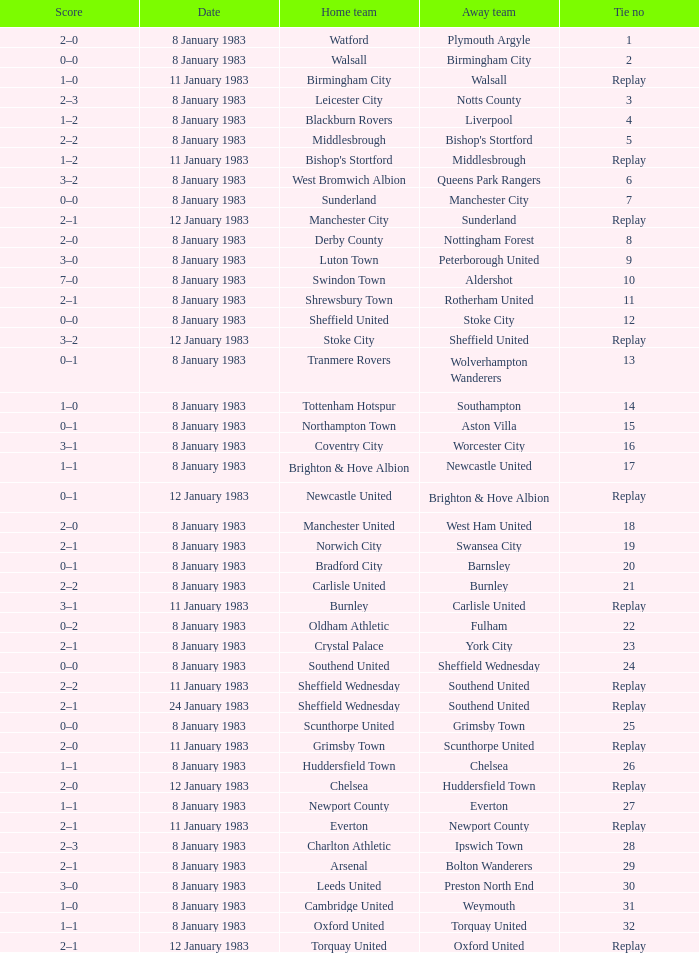In the tie where Southampton was the away team, who was the home team? Tottenham Hotspur. 